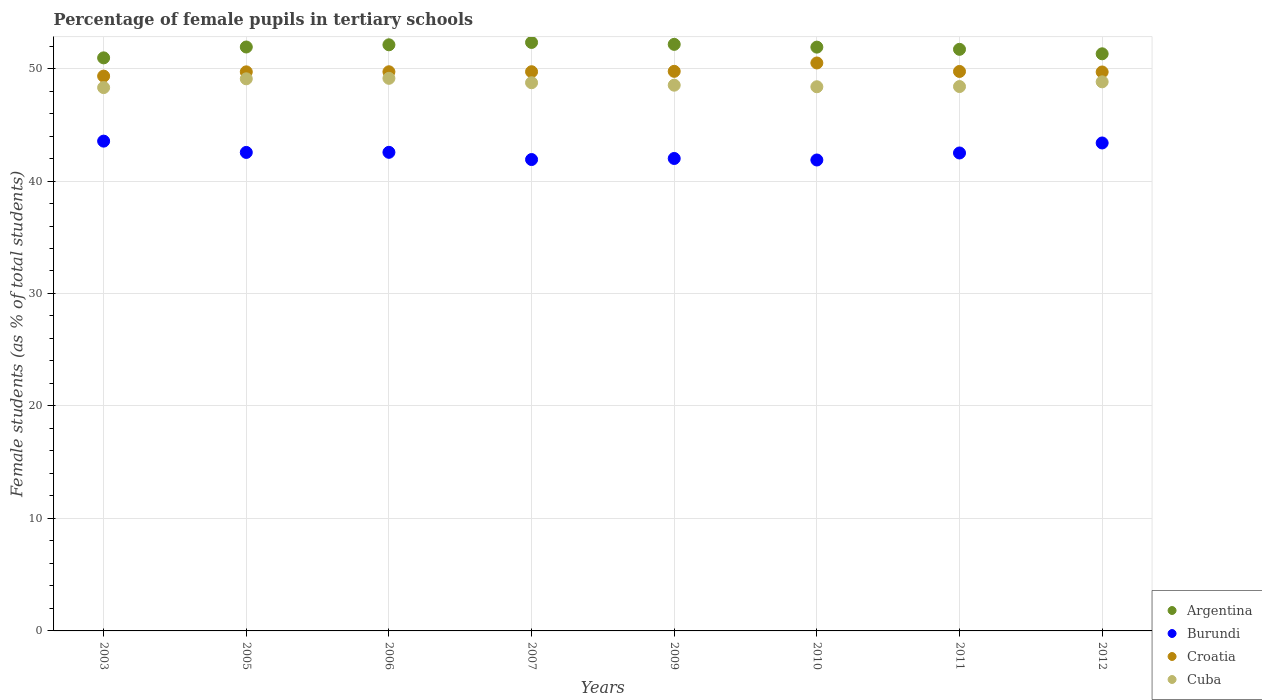How many different coloured dotlines are there?
Ensure brevity in your answer.  4. What is the percentage of female pupils in tertiary schools in Croatia in 2003?
Provide a short and direct response. 49.33. Across all years, what is the maximum percentage of female pupils in tertiary schools in Cuba?
Offer a very short reply. 49.13. Across all years, what is the minimum percentage of female pupils in tertiary schools in Cuba?
Offer a terse response. 48.31. In which year was the percentage of female pupils in tertiary schools in Cuba minimum?
Keep it short and to the point. 2003. What is the total percentage of female pupils in tertiary schools in Burundi in the graph?
Your answer should be very brief. 340.3. What is the difference between the percentage of female pupils in tertiary schools in Burundi in 2005 and that in 2011?
Ensure brevity in your answer.  0.05. What is the difference between the percentage of female pupils in tertiary schools in Croatia in 2003 and the percentage of female pupils in tertiary schools in Burundi in 2012?
Your response must be concise. 5.94. What is the average percentage of female pupils in tertiary schools in Burundi per year?
Your answer should be very brief. 42.54. In the year 2006, what is the difference between the percentage of female pupils in tertiary schools in Cuba and percentage of female pupils in tertiary schools in Burundi?
Your answer should be very brief. 6.58. In how many years, is the percentage of female pupils in tertiary schools in Burundi greater than 44 %?
Give a very brief answer. 0. What is the ratio of the percentage of female pupils in tertiary schools in Argentina in 2007 to that in 2010?
Provide a short and direct response. 1.01. What is the difference between the highest and the second highest percentage of female pupils in tertiary schools in Cuba?
Make the answer very short. 0.04. What is the difference between the highest and the lowest percentage of female pupils in tertiary schools in Cuba?
Keep it short and to the point. 0.82. In how many years, is the percentage of female pupils in tertiary schools in Argentina greater than the average percentage of female pupils in tertiary schools in Argentina taken over all years?
Keep it short and to the point. 5. Is it the case that in every year, the sum of the percentage of female pupils in tertiary schools in Argentina and percentage of female pupils in tertiary schools in Croatia  is greater than the sum of percentage of female pupils in tertiary schools in Cuba and percentage of female pupils in tertiary schools in Burundi?
Your response must be concise. Yes. How many dotlines are there?
Provide a succinct answer. 4. How many years are there in the graph?
Make the answer very short. 8. Are the values on the major ticks of Y-axis written in scientific E-notation?
Offer a very short reply. No. Does the graph contain any zero values?
Ensure brevity in your answer.  No. Does the graph contain grids?
Offer a very short reply. Yes. What is the title of the graph?
Your answer should be very brief. Percentage of female pupils in tertiary schools. What is the label or title of the X-axis?
Make the answer very short. Years. What is the label or title of the Y-axis?
Provide a succinct answer. Female students (as % of total students). What is the Female students (as % of total students) of Argentina in 2003?
Your response must be concise. 50.95. What is the Female students (as % of total students) of Burundi in 2003?
Offer a very short reply. 43.55. What is the Female students (as % of total students) of Croatia in 2003?
Keep it short and to the point. 49.33. What is the Female students (as % of total students) of Cuba in 2003?
Make the answer very short. 48.31. What is the Female students (as % of total students) in Argentina in 2005?
Give a very brief answer. 51.92. What is the Female students (as % of total students) of Burundi in 2005?
Offer a very short reply. 42.54. What is the Female students (as % of total students) in Croatia in 2005?
Give a very brief answer. 49.71. What is the Female students (as % of total students) of Cuba in 2005?
Provide a short and direct response. 49.09. What is the Female students (as % of total students) of Argentina in 2006?
Your answer should be very brief. 52.11. What is the Female students (as % of total students) of Burundi in 2006?
Provide a succinct answer. 42.55. What is the Female students (as % of total students) in Croatia in 2006?
Keep it short and to the point. 49.71. What is the Female students (as % of total students) in Cuba in 2006?
Ensure brevity in your answer.  49.13. What is the Female students (as % of total students) in Argentina in 2007?
Provide a succinct answer. 52.32. What is the Female students (as % of total students) of Burundi in 2007?
Offer a terse response. 41.91. What is the Female students (as % of total students) in Croatia in 2007?
Offer a terse response. 49.72. What is the Female students (as % of total students) in Cuba in 2007?
Provide a succinct answer. 48.74. What is the Female students (as % of total students) of Argentina in 2009?
Ensure brevity in your answer.  52.15. What is the Female students (as % of total students) in Burundi in 2009?
Give a very brief answer. 42. What is the Female students (as % of total students) of Croatia in 2009?
Keep it short and to the point. 49.75. What is the Female students (as % of total students) of Cuba in 2009?
Your response must be concise. 48.52. What is the Female students (as % of total students) in Argentina in 2010?
Your answer should be very brief. 51.9. What is the Female students (as % of total students) of Burundi in 2010?
Your answer should be compact. 41.87. What is the Female students (as % of total students) in Croatia in 2010?
Provide a succinct answer. 50.5. What is the Female students (as % of total students) in Cuba in 2010?
Provide a short and direct response. 48.38. What is the Female students (as % of total students) in Argentina in 2011?
Offer a terse response. 51.71. What is the Female students (as % of total students) of Burundi in 2011?
Provide a short and direct response. 42.49. What is the Female students (as % of total students) of Croatia in 2011?
Provide a short and direct response. 49.74. What is the Female students (as % of total students) in Cuba in 2011?
Keep it short and to the point. 48.4. What is the Female students (as % of total students) of Argentina in 2012?
Your answer should be very brief. 51.31. What is the Female students (as % of total students) in Burundi in 2012?
Provide a short and direct response. 43.38. What is the Female students (as % of total students) in Croatia in 2012?
Provide a short and direct response. 49.69. What is the Female students (as % of total students) in Cuba in 2012?
Your response must be concise. 48.82. Across all years, what is the maximum Female students (as % of total students) in Argentina?
Ensure brevity in your answer.  52.32. Across all years, what is the maximum Female students (as % of total students) in Burundi?
Provide a succinct answer. 43.55. Across all years, what is the maximum Female students (as % of total students) in Croatia?
Provide a succinct answer. 50.5. Across all years, what is the maximum Female students (as % of total students) in Cuba?
Offer a very short reply. 49.13. Across all years, what is the minimum Female students (as % of total students) of Argentina?
Your response must be concise. 50.95. Across all years, what is the minimum Female students (as % of total students) of Burundi?
Your answer should be very brief. 41.87. Across all years, what is the minimum Female students (as % of total students) of Croatia?
Provide a succinct answer. 49.33. Across all years, what is the minimum Female students (as % of total students) in Cuba?
Keep it short and to the point. 48.31. What is the total Female students (as % of total students) in Argentina in the graph?
Your response must be concise. 414.37. What is the total Female students (as % of total students) in Burundi in the graph?
Provide a short and direct response. 340.3. What is the total Female students (as % of total students) of Croatia in the graph?
Make the answer very short. 398.15. What is the total Female students (as % of total students) of Cuba in the graph?
Offer a terse response. 389.38. What is the difference between the Female students (as % of total students) in Argentina in 2003 and that in 2005?
Your response must be concise. -0.97. What is the difference between the Female students (as % of total students) in Croatia in 2003 and that in 2005?
Make the answer very short. -0.38. What is the difference between the Female students (as % of total students) in Cuba in 2003 and that in 2005?
Make the answer very short. -0.78. What is the difference between the Female students (as % of total students) in Argentina in 2003 and that in 2006?
Your answer should be very brief. -1.16. What is the difference between the Female students (as % of total students) of Croatia in 2003 and that in 2006?
Provide a short and direct response. -0.39. What is the difference between the Female students (as % of total students) of Cuba in 2003 and that in 2006?
Your response must be concise. -0.82. What is the difference between the Female students (as % of total students) of Argentina in 2003 and that in 2007?
Your answer should be very brief. -1.37. What is the difference between the Female students (as % of total students) of Burundi in 2003 and that in 2007?
Keep it short and to the point. 1.64. What is the difference between the Female students (as % of total students) of Croatia in 2003 and that in 2007?
Make the answer very short. -0.39. What is the difference between the Female students (as % of total students) of Cuba in 2003 and that in 2007?
Your answer should be very brief. -0.43. What is the difference between the Female students (as % of total students) of Argentina in 2003 and that in 2009?
Your answer should be very brief. -1.2. What is the difference between the Female students (as % of total students) in Burundi in 2003 and that in 2009?
Your response must be concise. 1.54. What is the difference between the Female students (as % of total students) in Croatia in 2003 and that in 2009?
Ensure brevity in your answer.  -0.42. What is the difference between the Female students (as % of total students) in Cuba in 2003 and that in 2009?
Your response must be concise. -0.21. What is the difference between the Female students (as % of total students) of Argentina in 2003 and that in 2010?
Your response must be concise. -0.95. What is the difference between the Female students (as % of total students) in Burundi in 2003 and that in 2010?
Offer a terse response. 1.68. What is the difference between the Female students (as % of total students) in Croatia in 2003 and that in 2010?
Offer a terse response. -1.17. What is the difference between the Female students (as % of total students) in Cuba in 2003 and that in 2010?
Keep it short and to the point. -0.07. What is the difference between the Female students (as % of total students) in Argentina in 2003 and that in 2011?
Offer a terse response. -0.76. What is the difference between the Female students (as % of total students) in Burundi in 2003 and that in 2011?
Your answer should be very brief. 1.05. What is the difference between the Female students (as % of total students) of Croatia in 2003 and that in 2011?
Give a very brief answer. -0.41. What is the difference between the Female students (as % of total students) of Cuba in 2003 and that in 2011?
Give a very brief answer. -0.09. What is the difference between the Female students (as % of total students) in Argentina in 2003 and that in 2012?
Make the answer very short. -0.36. What is the difference between the Female students (as % of total students) in Burundi in 2003 and that in 2012?
Your answer should be compact. 0.16. What is the difference between the Female students (as % of total students) in Croatia in 2003 and that in 2012?
Keep it short and to the point. -0.37. What is the difference between the Female students (as % of total students) in Cuba in 2003 and that in 2012?
Offer a very short reply. -0.51. What is the difference between the Female students (as % of total students) of Argentina in 2005 and that in 2006?
Your answer should be very brief. -0.2. What is the difference between the Female students (as % of total students) in Burundi in 2005 and that in 2006?
Offer a terse response. -0.01. What is the difference between the Female students (as % of total students) of Croatia in 2005 and that in 2006?
Give a very brief answer. -0.01. What is the difference between the Female students (as % of total students) of Cuba in 2005 and that in 2006?
Keep it short and to the point. -0.04. What is the difference between the Female students (as % of total students) in Argentina in 2005 and that in 2007?
Keep it short and to the point. -0.4. What is the difference between the Female students (as % of total students) in Burundi in 2005 and that in 2007?
Make the answer very short. 0.63. What is the difference between the Female students (as % of total students) of Croatia in 2005 and that in 2007?
Offer a terse response. -0.01. What is the difference between the Female students (as % of total students) in Cuba in 2005 and that in 2007?
Your answer should be very brief. 0.35. What is the difference between the Female students (as % of total students) of Argentina in 2005 and that in 2009?
Offer a very short reply. -0.23. What is the difference between the Female students (as % of total students) in Burundi in 2005 and that in 2009?
Give a very brief answer. 0.54. What is the difference between the Female students (as % of total students) in Croatia in 2005 and that in 2009?
Keep it short and to the point. -0.05. What is the difference between the Female students (as % of total students) in Cuba in 2005 and that in 2009?
Your response must be concise. 0.57. What is the difference between the Female students (as % of total students) in Argentina in 2005 and that in 2010?
Ensure brevity in your answer.  0.01. What is the difference between the Female students (as % of total students) of Burundi in 2005 and that in 2010?
Give a very brief answer. 0.67. What is the difference between the Female students (as % of total students) in Croatia in 2005 and that in 2010?
Your response must be concise. -0.79. What is the difference between the Female students (as % of total students) in Cuba in 2005 and that in 2010?
Your answer should be very brief. 0.71. What is the difference between the Female students (as % of total students) in Argentina in 2005 and that in 2011?
Make the answer very short. 0.21. What is the difference between the Female students (as % of total students) of Burundi in 2005 and that in 2011?
Your answer should be very brief. 0.05. What is the difference between the Female students (as % of total students) of Croatia in 2005 and that in 2011?
Make the answer very short. -0.04. What is the difference between the Female students (as % of total students) in Cuba in 2005 and that in 2011?
Your response must be concise. 0.69. What is the difference between the Female students (as % of total students) in Argentina in 2005 and that in 2012?
Make the answer very short. 0.6. What is the difference between the Female students (as % of total students) in Burundi in 2005 and that in 2012?
Your response must be concise. -0.84. What is the difference between the Female students (as % of total students) of Croatia in 2005 and that in 2012?
Offer a terse response. 0.01. What is the difference between the Female students (as % of total students) of Cuba in 2005 and that in 2012?
Provide a short and direct response. 0.27. What is the difference between the Female students (as % of total students) of Argentina in 2006 and that in 2007?
Keep it short and to the point. -0.21. What is the difference between the Female students (as % of total students) in Burundi in 2006 and that in 2007?
Give a very brief answer. 0.64. What is the difference between the Female students (as % of total students) in Croatia in 2006 and that in 2007?
Provide a succinct answer. -0. What is the difference between the Female students (as % of total students) in Cuba in 2006 and that in 2007?
Provide a succinct answer. 0.39. What is the difference between the Female students (as % of total students) of Argentina in 2006 and that in 2009?
Make the answer very short. -0.04. What is the difference between the Female students (as % of total students) of Burundi in 2006 and that in 2009?
Your answer should be very brief. 0.55. What is the difference between the Female students (as % of total students) of Croatia in 2006 and that in 2009?
Offer a very short reply. -0.04. What is the difference between the Female students (as % of total students) of Cuba in 2006 and that in 2009?
Provide a short and direct response. 0.61. What is the difference between the Female students (as % of total students) of Argentina in 2006 and that in 2010?
Your response must be concise. 0.21. What is the difference between the Female students (as % of total students) of Burundi in 2006 and that in 2010?
Your answer should be very brief. 0.68. What is the difference between the Female students (as % of total students) of Croatia in 2006 and that in 2010?
Keep it short and to the point. -0.78. What is the difference between the Female students (as % of total students) of Cuba in 2006 and that in 2010?
Your answer should be compact. 0.75. What is the difference between the Female students (as % of total students) of Argentina in 2006 and that in 2011?
Give a very brief answer. 0.4. What is the difference between the Female students (as % of total students) in Burundi in 2006 and that in 2011?
Your answer should be very brief. 0.06. What is the difference between the Female students (as % of total students) in Croatia in 2006 and that in 2011?
Your answer should be very brief. -0.03. What is the difference between the Female students (as % of total students) of Cuba in 2006 and that in 2011?
Provide a short and direct response. 0.73. What is the difference between the Female students (as % of total students) of Burundi in 2006 and that in 2012?
Provide a short and direct response. -0.83. What is the difference between the Female students (as % of total students) in Croatia in 2006 and that in 2012?
Keep it short and to the point. 0.02. What is the difference between the Female students (as % of total students) of Cuba in 2006 and that in 2012?
Make the answer very short. 0.31. What is the difference between the Female students (as % of total students) in Argentina in 2007 and that in 2009?
Offer a very short reply. 0.17. What is the difference between the Female students (as % of total students) of Burundi in 2007 and that in 2009?
Ensure brevity in your answer.  -0.09. What is the difference between the Female students (as % of total students) of Croatia in 2007 and that in 2009?
Make the answer very short. -0.03. What is the difference between the Female students (as % of total students) of Cuba in 2007 and that in 2009?
Your answer should be very brief. 0.22. What is the difference between the Female students (as % of total students) of Argentina in 2007 and that in 2010?
Provide a succinct answer. 0.42. What is the difference between the Female students (as % of total students) in Burundi in 2007 and that in 2010?
Provide a short and direct response. 0.04. What is the difference between the Female students (as % of total students) in Croatia in 2007 and that in 2010?
Your response must be concise. -0.78. What is the difference between the Female students (as % of total students) of Cuba in 2007 and that in 2010?
Offer a very short reply. 0.36. What is the difference between the Female students (as % of total students) in Argentina in 2007 and that in 2011?
Make the answer very short. 0.61. What is the difference between the Female students (as % of total students) in Burundi in 2007 and that in 2011?
Offer a very short reply. -0.58. What is the difference between the Female students (as % of total students) in Croatia in 2007 and that in 2011?
Your answer should be compact. -0.02. What is the difference between the Female students (as % of total students) in Cuba in 2007 and that in 2011?
Your answer should be compact. 0.34. What is the difference between the Female students (as % of total students) of Argentina in 2007 and that in 2012?
Make the answer very short. 1.01. What is the difference between the Female students (as % of total students) of Burundi in 2007 and that in 2012?
Provide a short and direct response. -1.47. What is the difference between the Female students (as % of total students) of Croatia in 2007 and that in 2012?
Offer a terse response. 0.02. What is the difference between the Female students (as % of total students) of Cuba in 2007 and that in 2012?
Your response must be concise. -0.08. What is the difference between the Female students (as % of total students) in Argentina in 2009 and that in 2010?
Keep it short and to the point. 0.25. What is the difference between the Female students (as % of total students) of Burundi in 2009 and that in 2010?
Your response must be concise. 0.13. What is the difference between the Female students (as % of total students) of Croatia in 2009 and that in 2010?
Ensure brevity in your answer.  -0.74. What is the difference between the Female students (as % of total students) in Cuba in 2009 and that in 2010?
Keep it short and to the point. 0.14. What is the difference between the Female students (as % of total students) in Argentina in 2009 and that in 2011?
Offer a terse response. 0.44. What is the difference between the Female students (as % of total students) of Burundi in 2009 and that in 2011?
Provide a succinct answer. -0.49. What is the difference between the Female students (as % of total students) in Croatia in 2009 and that in 2011?
Offer a very short reply. 0.01. What is the difference between the Female students (as % of total students) in Cuba in 2009 and that in 2011?
Your response must be concise. 0.12. What is the difference between the Female students (as % of total students) of Argentina in 2009 and that in 2012?
Your answer should be compact. 0.84. What is the difference between the Female students (as % of total students) of Burundi in 2009 and that in 2012?
Keep it short and to the point. -1.38. What is the difference between the Female students (as % of total students) of Croatia in 2009 and that in 2012?
Make the answer very short. 0.06. What is the difference between the Female students (as % of total students) of Cuba in 2009 and that in 2012?
Give a very brief answer. -0.3. What is the difference between the Female students (as % of total students) of Argentina in 2010 and that in 2011?
Keep it short and to the point. 0.2. What is the difference between the Female students (as % of total students) in Burundi in 2010 and that in 2011?
Your answer should be very brief. -0.62. What is the difference between the Female students (as % of total students) in Croatia in 2010 and that in 2011?
Provide a succinct answer. 0.75. What is the difference between the Female students (as % of total students) in Cuba in 2010 and that in 2011?
Give a very brief answer. -0.02. What is the difference between the Female students (as % of total students) of Argentina in 2010 and that in 2012?
Your answer should be compact. 0.59. What is the difference between the Female students (as % of total students) of Burundi in 2010 and that in 2012?
Provide a short and direct response. -1.51. What is the difference between the Female students (as % of total students) of Croatia in 2010 and that in 2012?
Ensure brevity in your answer.  0.8. What is the difference between the Female students (as % of total students) in Cuba in 2010 and that in 2012?
Give a very brief answer. -0.44. What is the difference between the Female students (as % of total students) of Argentina in 2011 and that in 2012?
Ensure brevity in your answer.  0.4. What is the difference between the Female students (as % of total students) in Burundi in 2011 and that in 2012?
Ensure brevity in your answer.  -0.89. What is the difference between the Female students (as % of total students) of Croatia in 2011 and that in 2012?
Ensure brevity in your answer.  0.05. What is the difference between the Female students (as % of total students) in Cuba in 2011 and that in 2012?
Your response must be concise. -0.42. What is the difference between the Female students (as % of total students) of Argentina in 2003 and the Female students (as % of total students) of Burundi in 2005?
Your answer should be very brief. 8.41. What is the difference between the Female students (as % of total students) of Argentina in 2003 and the Female students (as % of total students) of Croatia in 2005?
Offer a very short reply. 1.24. What is the difference between the Female students (as % of total students) of Argentina in 2003 and the Female students (as % of total students) of Cuba in 2005?
Give a very brief answer. 1.86. What is the difference between the Female students (as % of total students) of Burundi in 2003 and the Female students (as % of total students) of Croatia in 2005?
Ensure brevity in your answer.  -6.16. What is the difference between the Female students (as % of total students) of Burundi in 2003 and the Female students (as % of total students) of Cuba in 2005?
Your response must be concise. -5.54. What is the difference between the Female students (as % of total students) in Croatia in 2003 and the Female students (as % of total students) in Cuba in 2005?
Provide a succinct answer. 0.24. What is the difference between the Female students (as % of total students) of Argentina in 2003 and the Female students (as % of total students) of Burundi in 2006?
Give a very brief answer. 8.4. What is the difference between the Female students (as % of total students) in Argentina in 2003 and the Female students (as % of total students) in Croatia in 2006?
Make the answer very short. 1.24. What is the difference between the Female students (as % of total students) in Argentina in 2003 and the Female students (as % of total students) in Cuba in 2006?
Make the answer very short. 1.82. What is the difference between the Female students (as % of total students) of Burundi in 2003 and the Female students (as % of total students) of Croatia in 2006?
Ensure brevity in your answer.  -6.17. What is the difference between the Female students (as % of total students) of Burundi in 2003 and the Female students (as % of total students) of Cuba in 2006?
Offer a very short reply. -5.58. What is the difference between the Female students (as % of total students) of Croatia in 2003 and the Female students (as % of total students) of Cuba in 2006?
Your answer should be compact. 0.2. What is the difference between the Female students (as % of total students) in Argentina in 2003 and the Female students (as % of total students) in Burundi in 2007?
Make the answer very short. 9.04. What is the difference between the Female students (as % of total students) of Argentina in 2003 and the Female students (as % of total students) of Croatia in 2007?
Provide a succinct answer. 1.23. What is the difference between the Female students (as % of total students) of Argentina in 2003 and the Female students (as % of total students) of Cuba in 2007?
Provide a succinct answer. 2.21. What is the difference between the Female students (as % of total students) of Burundi in 2003 and the Female students (as % of total students) of Croatia in 2007?
Provide a succinct answer. -6.17. What is the difference between the Female students (as % of total students) of Burundi in 2003 and the Female students (as % of total students) of Cuba in 2007?
Your answer should be compact. -5.19. What is the difference between the Female students (as % of total students) of Croatia in 2003 and the Female students (as % of total students) of Cuba in 2007?
Provide a short and direct response. 0.59. What is the difference between the Female students (as % of total students) in Argentina in 2003 and the Female students (as % of total students) in Burundi in 2009?
Give a very brief answer. 8.95. What is the difference between the Female students (as % of total students) of Argentina in 2003 and the Female students (as % of total students) of Croatia in 2009?
Your answer should be very brief. 1.2. What is the difference between the Female students (as % of total students) in Argentina in 2003 and the Female students (as % of total students) in Cuba in 2009?
Ensure brevity in your answer.  2.43. What is the difference between the Female students (as % of total students) of Burundi in 2003 and the Female students (as % of total students) of Croatia in 2009?
Make the answer very short. -6.21. What is the difference between the Female students (as % of total students) in Burundi in 2003 and the Female students (as % of total students) in Cuba in 2009?
Keep it short and to the point. -4.97. What is the difference between the Female students (as % of total students) of Croatia in 2003 and the Female students (as % of total students) of Cuba in 2009?
Give a very brief answer. 0.81. What is the difference between the Female students (as % of total students) of Argentina in 2003 and the Female students (as % of total students) of Burundi in 2010?
Provide a succinct answer. 9.08. What is the difference between the Female students (as % of total students) in Argentina in 2003 and the Female students (as % of total students) in Croatia in 2010?
Ensure brevity in your answer.  0.45. What is the difference between the Female students (as % of total students) in Argentina in 2003 and the Female students (as % of total students) in Cuba in 2010?
Make the answer very short. 2.57. What is the difference between the Female students (as % of total students) of Burundi in 2003 and the Female students (as % of total students) of Croatia in 2010?
Offer a terse response. -6.95. What is the difference between the Female students (as % of total students) of Burundi in 2003 and the Female students (as % of total students) of Cuba in 2010?
Your answer should be compact. -4.84. What is the difference between the Female students (as % of total students) in Croatia in 2003 and the Female students (as % of total students) in Cuba in 2010?
Provide a short and direct response. 0.95. What is the difference between the Female students (as % of total students) of Argentina in 2003 and the Female students (as % of total students) of Burundi in 2011?
Provide a short and direct response. 8.46. What is the difference between the Female students (as % of total students) in Argentina in 2003 and the Female students (as % of total students) in Croatia in 2011?
Offer a very short reply. 1.21. What is the difference between the Female students (as % of total students) in Argentina in 2003 and the Female students (as % of total students) in Cuba in 2011?
Your response must be concise. 2.55. What is the difference between the Female students (as % of total students) in Burundi in 2003 and the Female students (as % of total students) in Croatia in 2011?
Give a very brief answer. -6.2. What is the difference between the Female students (as % of total students) of Burundi in 2003 and the Female students (as % of total students) of Cuba in 2011?
Ensure brevity in your answer.  -4.85. What is the difference between the Female students (as % of total students) in Croatia in 2003 and the Female students (as % of total students) in Cuba in 2011?
Provide a short and direct response. 0.93. What is the difference between the Female students (as % of total students) in Argentina in 2003 and the Female students (as % of total students) in Burundi in 2012?
Give a very brief answer. 7.57. What is the difference between the Female students (as % of total students) in Argentina in 2003 and the Female students (as % of total students) in Croatia in 2012?
Offer a very short reply. 1.25. What is the difference between the Female students (as % of total students) of Argentina in 2003 and the Female students (as % of total students) of Cuba in 2012?
Offer a terse response. 2.13. What is the difference between the Female students (as % of total students) in Burundi in 2003 and the Female students (as % of total students) in Croatia in 2012?
Your response must be concise. -6.15. What is the difference between the Female students (as % of total students) of Burundi in 2003 and the Female students (as % of total students) of Cuba in 2012?
Your answer should be compact. -5.27. What is the difference between the Female students (as % of total students) of Croatia in 2003 and the Female students (as % of total students) of Cuba in 2012?
Offer a very short reply. 0.51. What is the difference between the Female students (as % of total students) of Argentina in 2005 and the Female students (as % of total students) of Burundi in 2006?
Provide a succinct answer. 9.36. What is the difference between the Female students (as % of total students) in Argentina in 2005 and the Female students (as % of total students) in Croatia in 2006?
Keep it short and to the point. 2.2. What is the difference between the Female students (as % of total students) of Argentina in 2005 and the Female students (as % of total students) of Cuba in 2006?
Provide a short and direct response. 2.79. What is the difference between the Female students (as % of total students) in Burundi in 2005 and the Female students (as % of total students) in Croatia in 2006?
Give a very brief answer. -7.17. What is the difference between the Female students (as % of total students) of Burundi in 2005 and the Female students (as % of total students) of Cuba in 2006?
Offer a terse response. -6.59. What is the difference between the Female students (as % of total students) in Croatia in 2005 and the Female students (as % of total students) in Cuba in 2006?
Give a very brief answer. 0.58. What is the difference between the Female students (as % of total students) of Argentina in 2005 and the Female students (as % of total students) of Burundi in 2007?
Offer a very short reply. 10.01. What is the difference between the Female students (as % of total students) of Argentina in 2005 and the Female students (as % of total students) of Croatia in 2007?
Make the answer very short. 2.2. What is the difference between the Female students (as % of total students) in Argentina in 2005 and the Female students (as % of total students) in Cuba in 2007?
Keep it short and to the point. 3.18. What is the difference between the Female students (as % of total students) of Burundi in 2005 and the Female students (as % of total students) of Croatia in 2007?
Your answer should be very brief. -7.18. What is the difference between the Female students (as % of total students) in Burundi in 2005 and the Female students (as % of total students) in Cuba in 2007?
Give a very brief answer. -6.2. What is the difference between the Female students (as % of total students) in Croatia in 2005 and the Female students (as % of total students) in Cuba in 2007?
Provide a short and direct response. 0.97. What is the difference between the Female students (as % of total students) in Argentina in 2005 and the Female students (as % of total students) in Burundi in 2009?
Offer a terse response. 9.91. What is the difference between the Female students (as % of total students) of Argentina in 2005 and the Female students (as % of total students) of Croatia in 2009?
Offer a very short reply. 2.16. What is the difference between the Female students (as % of total students) of Argentina in 2005 and the Female students (as % of total students) of Cuba in 2009?
Keep it short and to the point. 3.39. What is the difference between the Female students (as % of total students) in Burundi in 2005 and the Female students (as % of total students) in Croatia in 2009?
Your answer should be compact. -7.21. What is the difference between the Female students (as % of total students) of Burundi in 2005 and the Female students (as % of total students) of Cuba in 2009?
Give a very brief answer. -5.98. What is the difference between the Female students (as % of total students) in Croatia in 2005 and the Female students (as % of total students) in Cuba in 2009?
Make the answer very short. 1.19. What is the difference between the Female students (as % of total students) of Argentina in 2005 and the Female students (as % of total students) of Burundi in 2010?
Ensure brevity in your answer.  10.05. What is the difference between the Female students (as % of total students) in Argentina in 2005 and the Female students (as % of total students) in Croatia in 2010?
Give a very brief answer. 1.42. What is the difference between the Female students (as % of total students) of Argentina in 2005 and the Female students (as % of total students) of Cuba in 2010?
Make the answer very short. 3.53. What is the difference between the Female students (as % of total students) of Burundi in 2005 and the Female students (as % of total students) of Croatia in 2010?
Offer a terse response. -7.95. What is the difference between the Female students (as % of total students) of Burundi in 2005 and the Female students (as % of total students) of Cuba in 2010?
Your answer should be compact. -5.84. What is the difference between the Female students (as % of total students) of Croatia in 2005 and the Female students (as % of total students) of Cuba in 2010?
Offer a very short reply. 1.33. What is the difference between the Female students (as % of total students) in Argentina in 2005 and the Female students (as % of total students) in Burundi in 2011?
Give a very brief answer. 9.42. What is the difference between the Female students (as % of total students) of Argentina in 2005 and the Female students (as % of total students) of Croatia in 2011?
Keep it short and to the point. 2.17. What is the difference between the Female students (as % of total students) of Argentina in 2005 and the Female students (as % of total students) of Cuba in 2011?
Your answer should be very brief. 3.52. What is the difference between the Female students (as % of total students) of Burundi in 2005 and the Female students (as % of total students) of Croatia in 2011?
Your answer should be very brief. -7.2. What is the difference between the Female students (as % of total students) of Burundi in 2005 and the Female students (as % of total students) of Cuba in 2011?
Provide a succinct answer. -5.86. What is the difference between the Female students (as % of total students) in Croatia in 2005 and the Female students (as % of total students) in Cuba in 2011?
Provide a short and direct response. 1.31. What is the difference between the Female students (as % of total students) in Argentina in 2005 and the Female students (as % of total students) in Burundi in 2012?
Give a very brief answer. 8.53. What is the difference between the Female students (as % of total students) of Argentina in 2005 and the Female students (as % of total students) of Croatia in 2012?
Your response must be concise. 2.22. What is the difference between the Female students (as % of total students) in Argentina in 2005 and the Female students (as % of total students) in Cuba in 2012?
Your answer should be compact. 3.1. What is the difference between the Female students (as % of total students) in Burundi in 2005 and the Female students (as % of total students) in Croatia in 2012?
Offer a terse response. -7.15. What is the difference between the Female students (as % of total students) in Burundi in 2005 and the Female students (as % of total students) in Cuba in 2012?
Offer a very short reply. -6.28. What is the difference between the Female students (as % of total students) of Croatia in 2005 and the Female students (as % of total students) of Cuba in 2012?
Offer a very short reply. 0.89. What is the difference between the Female students (as % of total students) in Argentina in 2006 and the Female students (as % of total students) in Burundi in 2007?
Provide a short and direct response. 10.2. What is the difference between the Female students (as % of total students) in Argentina in 2006 and the Female students (as % of total students) in Croatia in 2007?
Offer a very short reply. 2.39. What is the difference between the Female students (as % of total students) of Argentina in 2006 and the Female students (as % of total students) of Cuba in 2007?
Your response must be concise. 3.37. What is the difference between the Female students (as % of total students) in Burundi in 2006 and the Female students (as % of total students) in Croatia in 2007?
Make the answer very short. -7.17. What is the difference between the Female students (as % of total students) of Burundi in 2006 and the Female students (as % of total students) of Cuba in 2007?
Offer a terse response. -6.19. What is the difference between the Female students (as % of total students) in Croatia in 2006 and the Female students (as % of total students) in Cuba in 2007?
Offer a terse response. 0.97. What is the difference between the Female students (as % of total students) in Argentina in 2006 and the Female students (as % of total students) in Burundi in 2009?
Your response must be concise. 10.11. What is the difference between the Female students (as % of total students) in Argentina in 2006 and the Female students (as % of total students) in Croatia in 2009?
Your response must be concise. 2.36. What is the difference between the Female students (as % of total students) of Argentina in 2006 and the Female students (as % of total students) of Cuba in 2009?
Your response must be concise. 3.59. What is the difference between the Female students (as % of total students) of Burundi in 2006 and the Female students (as % of total students) of Croatia in 2009?
Ensure brevity in your answer.  -7.2. What is the difference between the Female students (as % of total students) in Burundi in 2006 and the Female students (as % of total students) in Cuba in 2009?
Provide a short and direct response. -5.97. What is the difference between the Female students (as % of total students) of Croatia in 2006 and the Female students (as % of total students) of Cuba in 2009?
Make the answer very short. 1.19. What is the difference between the Female students (as % of total students) of Argentina in 2006 and the Female students (as % of total students) of Burundi in 2010?
Your answer should be very brief. 10.24. What is the difference between the Female students (as % of total students) of Argentina in 2006 and the Female students (as % of total students) of Croatia in 2010?
Provide a short and direct response. 1.62. What is the difference between the Female students (as % of total students) in Argentina in 2006 and the Female students (as % of total students) in Cuba in 2010?
Give a very brief answer. 3.73. What is the difference between the Female students (as % of total students) in Burundi in 2006 and the Female students (as % of total students) in Croatia in 2010?
Provide a succinct answer. -7.94. What is the difference between the Female students (as % of total students) of Burundi in 2006 and the Female students (as % of total students) of Cuba in 2010?
Your answer should be very brief. -5.83. What is the difference between the Female students (as % of total students) of Croatia in 2006 and the Female students (as % of total students) of Cuba in 2010?
Provide a succinct answer. 1.33. What is the difference between the Female students (as % of total students) in Argentina in 2006 and the Female students (as % of total students) in Burundi in 2011?
Offer a very short reply. 9.62. What is the difference between the Female students (as % of total students) in Argentina in 2006 and the Female students (as % of total students) in Croatia in 2011?
Make the answer very short. 2.37. What is the difference between the Female students (as % of total students) of Argentina in 2006 and the Female students (as % of total students) of Cuba in 2011?
Give a very brief answer. 3.71. What is the difference between the Female students (as % of total students) in Burundi in 2006 and the Female students (as % of total students) in Croatia in 2011?
Provide a short and direct response. -7.19. What is the difference between the Female students (as % of total students) in Burundi in 2006 and the Female students (as % of total students) in Cuba in 2011?
Provide a succinct answer. -5.85. What is the difference between the Female students (as % of total students) in Croatia in 2006 and the Female students (as % of total students) in Cuba in 2011?
Provide a succinct answer. 1.31. What is the difference between the Female students (as % of total students) of Argentina in 2006 and the Female students (as % of total students) of Burundi in 2012?
Your answer should be very brief. 8.73. What is the difference between the Female students (as % of total students) of Argentina in 2006 and the Female students (as % of total students) of Croatia in 2012?
Provide a succinct answer. 2.42. What is the difference between the Female students (as % of total students) of Argentina in 2006 and the Female students (as % of total students) of Cuba in 2012?
Ensure brevity in your answer.  3.29. What is the difference between the Female students (as % of total students) in Burundi in 2006 and the Female students (as % of total students) in Croatia in 2012?
Your response must be concise. -7.14. What is the difference between the Female students (as % of total students) of Burundi in 2006 and the Female students (as % of total students) of Cuba in 2012?
Your answer should be very brief. -6.27. What is the difference between the Female students (as % of total students) in Croatia in 2006 and the Female students (as % of total students) in Cuba in 2012?
Ensure brevity in your answer.  0.9. What is the difference between the Female students (as % of total students) in Argentina in 2007 and the Female students (as % of total students) in Burundi in 2009?
Keep it short and to the point. 10.32. What is the difference between the Female students (as % of total students) in Argentina in 2007 and the Female students (as % of total students) in Croatia in 2009?
Your response must be concise. 2.57. What is the difference between the Female students (as % of total students) in Argentina in 2007 and the Female students (as % of total students) in Cuba in 2009?
Your response must be concise. 3.8. What is the difference between the Female students (as % of total students) of Burundi in 2007 and the Female students (as % of total students) of Croatia in 2009?
Offer a terse response. -7.84. What is the difference between the Female students (as % of total students) in Burundi in 2007 and the Female students (as % of total students) in Cuba in 2009?
Your answer should be very brief. -6.61. What is the difference between the Female students (as % of total students) in Croatia in 2007 and the Female students (as % of total students) in Cuba in 2009?
Give a very brief answer. 1.2. What is the difference between the Female students (as % of total students) in Argentina in 2007 and the Female students (as % of total students) in Burundi in 2010?
Your answer should be very brief. 10.45. What is the difference between the Female students (as % of total students) of Argentina in 2007 and the Female students (as % of total students) of Croatia in 2010?
Give a very brief answer. 1.82. What is the difference between the Female students (as % of total students) of Argentina in 2007 and the Female students (as % of total students) of Cuba in 2010?
Give a very brief answer. 3.94. What is the difference between the Female students (as % of total students) of Burundi in 2007 and the Female students (as % of total students) of Croatia in 2010?
Provide a succinct answer. -8.59. What is the difference between the Female students (as % of total students) in Burundi in 2007 and the Female students (as % of total students) in Cuba in 2010?
Your response must be concise. -6.47. What is the difference between the Female students (as % of total students) in Croatia in 2007 and the Female students (as % of total students) in Cuba in 2010?
Keep it short and to the point. 1.34. What is the difference between the Female students (as % of total students) in Argentina in 2007 and the Female students (as % of total students) in Burundi in 2011?
Offer a terse response. 9.83. What is the difference between the Female students (as % of total students) of Argentina in 2007 and the Female students (as % of total students) of Croatia in 2011?
Offer a very short reply. 2.58. What is the difference between the Female students (as % of total students) of Argentina in 2007 and the Female students (as % of total students) of Cuba in 2011?
Make the answer very short. 3.92. What is the difference between the Female students (as % of total students) in Burundi in 2007 and the Female students (as % of total students) in Croatia in 2011?
Make the answer very short. -7.83. What is the difference between the Female students (as % of total students) in Burundi in 2007 and the Female students (as % of total students) in Cuba in 2011?
Your answer should be very brief. -6.49. What is the difference between the Female students (as % of total students) in Croatia in 2007 and the Female students (as % of total students) in Cuba in 2011?
Provide a succinct answer. 1.32. What is the difference between the Female students (as % of total students) of Argentina in 2007 and the Female students (as % of total students) of Burundi in 2012?
Your answer should be compact. 8.94. What is the difference between the Female students (as % of total students) in Argentina in 2007 and the Female students (as % of total students) in Croatia in 2012?
Your answer should be very brief. 2.63. What is the difference between the Female students (as % of total students) of Argentina in 2007 and the Female students (as % of total students) of Cuba in 2012?
Your answer should be very brief. 3.5. What is the difference between the Female students (as % of total students) in Burundi in 2007 and the Female students (as % of total students) in Croatia in 2012?
Provide a succinct answer. -7.78. What is the difference between the Female students (as % of total students) of Burundi in 2007 and the Female students (as % of total students) of Cuba in 2012?
Give a very brief answer. -6.91. What is the difference between the Female students (as % of total students) in Croatia in 2007 and the Female students (as % of total students) in Cuba in 2012?
Give a very brief answer. 0.9. What is the difference between the Female students (as % of total students) in Argentina in 2009 and the Female students (as % of total students) in Burundi in 2010?
Provide a short and direct response. 10.28. What is the difference between the Female students (as % of total students) in Argentina in 2009 and the Female students (as % of total students) in Croatia in 2010?
Give a very brief answer. 1.65. What is the difference between the Female students (as % of total students) of Argentina in 2009 and the Female students (as % of total students) of Cuba in 2010?
Your response must be concise. 3.77. What is the difference between the Female students (as % of total students) in Burundi in 2009 and the Female students (as % of total students) in Croatia in 2010?
Keep it short and to the point. -8.49. What is the difference between the Female students (as % of total students) in Burundi in 2009 and the Female students (as % of total students) in Cuba in 2010?
Offer a terse response. -6.38. What is the difference between the Female students (as % of total students) of Croatia in 2009 and the Female students (as % of total students) of Cuba in 2010?
Give a very brief answer. 1.37. What is the difference between the Female students (as % of total students) of Argentina in 2009 and the Female students (as % of total students) of Burundi in 2011?
Give a very brief answer. 9.66. What is the difference between the Female students (as % of total students) in Argentina in 2009 and the Female students (as % of total students) in Croatia in 2011?
Offer a terse response. 2.41. What is the difference between the Female students (as % of total students) in Argentina in 2009 and the Female students (as % of total students) in Cuba in 2011?
Ensure brevity in your answer.  3.75. What is the difference between the Female students (as % of total students) in Burundi in 2009 and the Female students (as % of total students) in Croatia in 2011?
Keep it short and to the point. -7.74. What is the difference between the Female students (as % of total students) of Burundi in 2009 and the Female students (as % of total students) of Cuba in 2011?
Your response must be concise. -6.4. What is the difference between the Female students (as % of total students) of Croatia in 2009 and the Female students (as % of total students) of Cuba in 2011?
Make the answer very short. 1.35. What is the difference between the Female students (as % of total students) of Argentina in 2009 and the Female students (as % of total students) of Burundi in 2012?
Your answer should be compact. 8.77. What is the difference between the Female students (as % of total students) of Argentina in 2009 and the Female students (as % of total students) of Croatia in 2012?
Your answer should be very brief. 2.45. What is the difference between the Female students (as % of total students) in Argentina in 2009 and the Female students (as % of total students) in Cuba in 2012?
Provide a short and direct response. 3.33. What is the difference between the Female students (as % of total students) in Burundi in 2009 and the Female students (as % of total students) in Croatia in 2012?
Your answer should be very brief. -7.69. What is the difference between the Female students (as % of total students) of Burundi in 2009 and the Female students (as % of total students) of Cuba in 2012?
Offer a very short reply. -6.81. What is the difference between the Female students (as % of total students) in Croatia in 2009 and the Female students (as % of total students) in Cuba in 2012?
Keep it short and to the point. 0.93. What is the difference between the Female students (as % of total students) in Argentina in 2010 and the Female students (as % of total students) in Burundi in 2011?
Make the answer very short. 9.41. What is the difference between the Female students (as % of total students) in Argentina in 2010 and the Female students (as % of total students) in Croatia in 2011?
Give a very brief answer. 2.16. What is the difference between the Female students (as % of total students) of Argentina in 2010 and the Female students (as % of total students) of Cuba in 2011?
Offer a very short reply. 3.5. What is the difference between the Female students (as % of total students) of Burundi in 2010 and the Female students (as % of total students) of Croatia in 2011?
Give a very brief answer. -7.87. What is the difference between the Female students (as % of total students) of Burundi in 2010 and the Female students (as % of total students) of Cuba in 2011?
Provide a short and direct response. -6.53. What is the difference between the Female students (as % of total students) of Croatia in 2010 and the Female students (as % of total students) of Cuba in 2011?
Provide a short and direct response. 2.1. What is the difference between the Female students (as % of total students) in Argentina in 2010 and the Female students (as % of total students) in Burundi in 2012?
Your answer should be very brief. 8.52. What is the difference between the Female students (as % of total students) in Argentina in 2010 and the Female students (as % of total students) in Croatia in 2012?
Offer a very short reply. 2.21. What is the difference between the Female students (as % of total students) in Argentina in 2010 and the Female students (as % of total students) in Cuba in 2012?
Keep it short and to the point. 3.09. What is the difference between the Female students (as % of total students) in Burundi in 2010 and the Female students (as % of total students) in Croatia in 2012?
Offer a very short reply. -7.83. What is the difference between the Female students (as % of total students) of Burundi in 2010 and the Female students (as % of total students) of Cuba in 2012?
Keep it short and to the point. -6.95. What is the difference between the Female students (as % of total students) in Croatia in 2010 and the Female students (as % of total students) in Cuba in 2012?
Your answer should be compact. 1.68. What is the difference between the Female students (as % of total students) in Argentina in 2011 and the Female students (as % of total students) in Burundi in 2012?
Your answer should be compact. 8.33. What is the difference between the Female students (as % of total students) in Argentina in 2011 and the Female students (as % of total students) in Croatia in 2012?
Ensure brevity in your answer.  2.01. What is the difference between the Female students (as % of total students) in Argentina in 2011 and the Female students (as % of total students) in Cuba in 2012?
Make the answer very short. 2.89. What is the difference between the Female students (as % of total students) in Burundi in 2011 and the Female students (as % of total students) in Croatia in 2012?
Provide a short and direct response. -7.2. What is the difference between the Female students (as % of total students) of Burundi in 2011 and the Female students (as % of total students) of Cuba in 2012?
Provide a succinct answer. -6.33. What is the difference between the Female students (as % of total students) of Croatia in 2011 and the Female students (as % of total students) of Cuba in 2012?
Provide a short and direct response. 0.92. What is the average Female students (as % of total students) in Argentina per year?
Your response must be concise. 51.8. What is the average Female students (as % of total students) of Burundi per year?
Give a very brief answer. 42.54. What is the average Female students (as % of total students) in Croatia per year?
Your answer should be very brief. 49.77. What is the average Female students (as % of total students) of Cuba per year?
Offer a terse response. 48.67. In the year 2003, what is the difference between the Female students (as % of total students) of Argentina and Female students (as % of total students) of Burundi?
Ensure brevity in your answer.  7.4. In the year 2003, what is the difference between the Female students (as % of total students) of Argentina and Female students (as % of total students) of Croatia?
Provide a succinct answer. 1.62. In the year 2003, what is the difference between the Female students (as % of total students) of Argentina and Female students (as % of total students) of Cuba?
Give a very brief answer. 2.64. In the year 2003, what is the difference between the Female students (as % of total students) in Burundi and Female students (as % of total students) in Croatia?
Your response must be concise. -5.78. In the year 2003, what is the difference between the Female students (as % of total students) in Burundi and Female students (as % of total students) in Cuba?
Offer a very short reply. -4.76. In the year 2003, what is the difference between the Female students (as % of total students) of Croatia and Female students (as % of total students) of Cuba?
Provide a succinct answer. 1.02. In the year 2005, what is the difference between the Female students (as % of total students) in Argentina and Female students (as % of total students) in Burundi?
Provide a succinct answer. 9.37. In the year 2005, what is the difference between the Female students (as % of total students) of Argentina and Female students (as % of total students) of Croatia?
Ensure brevity in your answer.  2.21. In the year 2005, what is the difference between the Female students (as % of total students) in Argentina and Female students (as % of total students) in Cuba?
Provide a short and direct response. 2.83. In the year 2005, what is the difference between the Female students (as % of total students) of Burundi and Female students (as % of total students) of Croatia?
Make the answer very short. -7.16. In the year 2005, what is the difference between the Female students (as % of total students) of Burundi and Female students (as % of total students) of Cuba?
Keep it short and to the point. -6.55. In the year 2005, what is the difference between the Female students (as % of total students) of Croatia and Female students (as % of total students) of Cuba?
Ensure brevity in your answer.  0.62. In the year 2006, what is the difference between the Female students (as % of total students) in Argentina and Female students (as % of total students) in Burundi?
Give a very brief answer. 9.56. In the year 2006, what is the difference between the Female students (as % of total students) in Argentina and Female students (as % of total students) in Croatia?
Your response must be concise. 2.4. In the year 2006, what is the difference between the Female students (as % of total students) in Argentina and Female students (as % of total students) in Cuba?
Your answer should be compact. 2.98. In the year 2006, what is the difference between the Female students (as % of total students) in Burundi and Female students (as % of total students) in Croatia?
Provide a short and direct response. -7.16. In the year 2006, what is the difference between the Female students (as % of total students) of Burundi and Female students (as % of total students) of Cuba?
Make the answer very short. -6.58. In the year 2006, what is the difference between the Female students (as % of total students) of Croatia and Female students (as % of total students) of Cuba?
Keep it short and to the point. 0.58. In the year 2007, what is the difference between the Female students (as % of total students) in Argentina and Female students (as % of total students) in Burundi?
Your response must be concise. 10.41. In the year 2007, what is the difference between the Female students (as % of total students) of Argentina and Female students (as % of total students) of Croatia?
Ensure brevity in your answer.  2.6. In the year 2007, what is the difference between the Female students (as % of total students) in Argentina and Female students (as % of total students) in Cuba?
Make the answer very short. 3.58. In the year 2007, what is the difference between the Female students (as % of total students) of Burundi and Female students (as % of total students) of Croatia?
Your answer should be compact. -7.81. In the year 2007, what is the difference between the Female students (as % of total students) in Burundi and Female students (as % of total students) in Cuba?
Keep it short and to the point. -6.83. In the year 2007, what is the difference between the Female students (as % of total students) of Croatia and Female students (as % of total students) of Cuba?
Your answer should be very brief. 0.98. In the year 2009, what is the difference between the Female students (as % of total students) in Argentina and Female students (as % of total students) in Burundi?
Your answer should be compact. 10.15. In the year 2009, what is the difference between the Female students (as % of total students) in Argentina and Female students (as % of total students) in Croatia?
Your answer should be very brief. 2.4. In the year 2009, what is the difference between the Female students (as % of total students) of Argentina and Female students (as % of total students) of Cuba?
Offer a terse response. 3.63. In the year 2009, what is the difference between the Female students (as % of total students) in Burundi and Female students (as % of total students) in Croatia?
Offer a very short reply. -7.75. In the year 2009, what is the difference between the Female students (as % of total students) in Burundi and Female students (as % of total students) in Cuba?
Provide a short and direct response. -6.52. In the year 2009, what is the difference between the Female students (as % of total students) in Croatia and Female students (as % of total students) in Cuba?
Ensure brevity in your answer.  1.23. In the year 2010, what is the difference between the Female students (as % of total students) of Argentina and Female students (as % of total students) of Burundi?
Ensure brevity in your answer.  10.03. In the year 2010, what is the difference between the Female students (as % of total students) of Argentina and Female students (as % of total students) of Croatia?
Keep it short and to the point. 1.41. In the year 2010, what is the difference between the Female students (as % of total students) of Argentina and Female students (as % of total students) of Cuba?
Your answer should be very brief. 3.52. In the year 2010, what is the difference between the Female students (as % of total students) in Burundi and Female students (as % of total students) in Croatia?
Keep it short and to the point. -8.63. In the year 2010, what is the difference between the Female students (as % of total students) of Burundi and Female students (as % of total students) of Cuba?
Ensure brevity in your answer.  -6.51. In the year 2010, what is the difference between the Female students (as % of total students) of Croatia and Female students (as % of total students) of Cuba?
Offer a very short reply. 2.11. In the year 2011, what is the difference between the Female students (as % of total students) in Argentina and Female students (as % of total students) in Burundi?
Your answer should be very brief. 9.22. In the year 2011, what is the difference between the Female students (as % of total students) of Argentina and Female students (as % of total students) of Croatia?
Give a very brief answer. 1.97. In the year 2011, what is the difference between the Female students (as % of total students) of Argentina and Female students (as % of total students) of Cuba?
Offer a terse response. 3.31. In the year 2011, what is the difference between the Female students (as % of total students) in Burundi and Female students (as % of total students) in Croatia?
Offer a very short reply. -7.25. In the year 2011, what is the difference between the Female students (as % of total students) in Burundi and Female students (as % of total students) in Cuba?
Your response must be concise. -5.91. In the year 2011, what is the difference between the Female students (as % of total students) of Croatia and Female students (as % of total students) of Cuba?
Offer a very short reply. 1.34. In the year 2012, what is the difference between the Female students (as % of total students) of Argentina and Female students (as % of total students) of Burundi?
Keep it short and to the point. 7.93. In the year 2012, what is the difference between the Female students (as % of total students) in Argentina and Female students (as % of total students) in Croatia?
Offer a very short reply. 1.62. In the year 2012, what is the difference between the Female students (as % of total students) in Argentina and Female students (as % of total students) in Cuba?
Offer a terse response. 2.49. In the year 2012, what is the difference between the Female students (as % of total students) in Burundi and Female students (as % of total students) in Croatia?
Your answer should be very brief. -6.31. In the year 2012, what is the difference between the Female students (as % of total students) in Burundi and Female students (as % of total students) in Cuba?
Provide a succinct answer. -5.44. In the year 2012, what is the difference between the Female students (as % of total students) in Croatia and Female students (as % of total students) in Cuba?
Provide a short and direct response. 0.88. What is the ratio of the Female students (as % of total students) of Argentina in 2003 to that in 2005?
Offer a very short reply. 0.98. What is the ratio of the Female students (as % of total students) of Burundi in 2003 to that in 2005?
Your answer should be compact. 1.02. What is the ratio of the Female students (as % of total students) in Croatia in 2003 to that in 2005?
Offer a very short reply. 0.99. What is the ratio of the Female students (as % of total students) of Cuba in 2003 to that in 2005?
Make the answer very short. 0.98. What is the ratio of the Female students (as % of total students) of Argentina in 2003 to that in 2006?
Ensure brevity in your answer.  0.98. What is the ratio of the Female students (as % of total students) in Burundi in 2003 to that in 2006?
Your answer should be very brief. 1.02. What is the ratio of the Female students (as % of total students) of Cuba in 2003 to that in 2006?
Your response must be concise. 0.98. What is the ratio of the Female students (as % of total students) of Argentina in 2003 to that in 2007?
Your answer should be very brief. 0.97. What is the ratio of the Female students (as % of total students) in Burundi in 2003 to that in 2007?
Offer a terse response. 1.04. What is the ratio of the Female students (as % of total students) in Argentina in 2003 to that in 2009?
Your answer should be compact. 0.98. What is the ratio of the Female students (as % of total students) of Burundi in 2003 to that in 2009?
Your answer should be compact. 1.04. What is the ratio of the Female students (as % of total students) of Argentina in 2003 to that in 2010?
Give a very brief answer. 0.98. What is the ratio of the Female students (as % of total students) of Burundi in 2003 to that in 2010?
Keep it short and to the point. 1.04. What is the ratio of the Female students (as % of total students) in Croatia in 2003 to that in 2010?
Your response must be concise. 0.98. What is the ratio of the Female students (as % of total students) of Burundi in 2003 to that in 2011?
Ensure brevity in your answer.  1.02. What is the ratio of the Female students (as % of total students) of Argentina in 2003 to that in 2012?
Your answer should be compact. 0.99. What is the ratio of the Female students (as % of total students) in Burundi in 2003 to that in 2012?
Keep it short and to the point. 1. What is the ratio of the Female students (as % of total students) of Burundi in 2005 to that in 2007?
Your answer should be compact. 1.02. What is the ratio of the Female students (as % of total students) of Cuba in 2005 to that in 2007?
Make the answer very short. 1.01. What is the ratio of the Female students (as % of total students) in Argentina in 2005 to that in 2009?
Keep it short and to the point. 1. What is the ratio of the Female students (as % of total students) in Burundi in 2005 to that in 2009?
Your answer should be compact. 1.01. What is the ratio of the Female students (as % of total students) of Cuba in 2005 to that in 2009?
Make the answer very short. 1.01. What is the ratio of the Female students (as % of total students) of Argentina in 2005 to that in 2010?
Your answer should be very brief. 1. What is the ratio of the Female students (as % of total students) of Burundi in 2005 to that in 2010?
Give a very brief answer. 1.02. What is the ratio of the Female students (as % of total students) of Croatia in 2005 to that in 2010?
Ensure brevity in your answer.  0.98. What is the ratio of the Female students (as % of total students) of Cuba in 2005 to that in 2010?
Make the answer very short. 1.01. What is the ratio of the Female students (as % of total students) in Burundi in 2005 to that in 2011?
Provide a short and direct response. 1. What is the ratio of the Female students (as % of total students) of Cuba in 2005 to that in 2011?
Ensure brevity in your answer.  1.01. What is the ratio of the Female students (as % of total students) in Argentina in 2005 to that in 2012?
Provide a succinct answer. 1.01. What is the ratio of the Female students (as % of total students) in Burundi in 2005 to that in 2012?
Offer a terse response. 0.98. What is the ratio of the Female students (as % of total students) in Cuba in 2005 to that in 2012?
Your answer should be compact. 1.01. What is the ratio of the Female students (as % of total students) of Burundi in 2006 to that in 2007?
Your answer should be very brief. 1.02. What is the ratio of the Female students (as % of total students) in Croatia in 2006 to that in 2007?
Provide a short and direct response. 1. What is the ratio of the Female students (as % of total students) in Argentina in 2006 to that in 2009?
Provide a short and direct response. 1. What is the ratio of the Female students (as % of total students) in Cuba in 2006 to that in 2009?
Offer a terse response. 1.01. What is the ratio of the Female students (as % of total students) of Burundi in 2006 to that in 2010?
Offer a terse response. 1.02. What is the ratio of the Female students (as % of total students) of Croatia in 2006 to that in 2010?
Give a very brief answer. 0.98. What is the ratio of the Female students (as % of total students) of Cuba in 2006 to that in 2010?
Offer a terse response. 1.02. What is the ratio of the Female students (as % of total students) in Argentina in 2006 to that in 2011?
Ensure brevity in your answer.  1.01. What is the ratio of the Female students (as % of total students) in Burundi in 2006 to that in 2011?
Keep it short and to the point. 1. What is the ratio of the Female students (as % of total students) of Croatia in 2006 to that in 2011?
Give a very brief answer. 1. What is the ratio of the Female students (as % of total students) in Cuba in 2006 to that in 2011?
Make the answer very short. 1.02. What is the ratio of the Female students (as % of total students) of Argentina in 2006 to that in 2012?
Provide a short and direct response. 1.02. What is the ratio of the Female students (as % of total students) in Burundi in 2006 to that in 2012?
Your answer should be very brief. 0.98. What is the ratio of the Female students (as % of total students) in Cuba in 2006 to that in 2012?
Your answer should be compact. 1.01. What is the ratio of the Female students (as % of total students) of Burundi in 2007 to that in 2009?
Your answer should be compact. 1. What is the ratio of the Female students (as % of total students) in Cuba in 2007 to that in 2009?
Ensure brevity in your answer.  1. What is the ratio of the Female students (as % of total students) of Croatia in 2007 to that in 2010?
Offer a terse response. 0.98. What is the ratio of the Female students (as % of total students) of Cuba in 2007 to that in 2010?
Provide a succinct answer. 1.01. What is the ratio of the Female students (as % of total students) of Argentina in 2007 to that in 2011?
Your answer should be very brief. 1.01. What is the ratio of the Female students (as % of total students) of Burundi in 2007 to that in 2011?
Offer a very short reply. 0.99. What is the ratio of the Female students (as % of total students) in Cuba in 2007 to that in 2011?
Provide a succinct answer. 1.01. What is the ratio of the Female students (as % of total students) in Argentina in 2007 to that in 2012?
Offer a very short reply. 1.02. What is the ratio of the Female students (as % of total students) of Croatia in 2007 to that in 2012?
Make the answer very short. 1. What is the ratio of the Female students (as % of total students) in Burundi in 2009 to that in 2010?
Make the answer very short. 1. What is the ratio of the Female students (as % of total students) of Croatia in 2009 to that in 2010?
Provide a short and direct response. 0.99. What is the ratio of the Female students (as % of total students) of Cuba in 2009 to that in 2010?
Your answer should be compact. 1. What is the ratio of the Female students (as % of total students) of Argentina in 2009 to that in 2011?
Provide a short and direct response. 1.01. What is the ratio of the Female students (as % of total students) in Cuba in 2009 to that in 2011?
Make the answer very short. 1. What is the ratio of the Female students (as % of total students) of Argentina in 2009 to that in 2012?
Ensure brevity in your answer.  1.02. What is the ratio of the Female students (as % of total students) of Burundi in 2009 to that in 2012?
Give a very brief answer. 0.97. What is the ratio of the Female students (as % of total students) of Croatia in 2009 to that in 2012?
Provide a succinct answer. 1. What is the ratio of the Female students (as % of total students) of Cuba in 2009 to that in 2012?
Your answer should be very brief. 0.99. What is the ratio of the Female students (as % of total students) in Croatia in 2010 to that in 2011?
Make the answer very short. 1.02. What is the ratio of the Female students (as % of total students) in Argentina in 2010 to that in 2012?
Make the answer very short. 1.01. What is the ratio of the Female students (as % of total students) in Burundi in 2010 to that in 2012?
Keep it short and to the point. 0.97. What is the ratio of the Female students (as % of total students) in Croatia in 2010 to that in 2012?
Your answer should be compact. 1.02. What is the ratio of the Female students (as % of total students) in Argentina in 2011 to that in 2012?
Offer a very short reply. 1.01. What is the ratio of the Female students (as % of total students) in Burundi in 2011 to that in 2012?
Your answer should be very brief. 0.98. What is the difference between the highest and the second highest Female students (as % of total students) in Argentina?
Provide a succinct answer. 0.17. What is the difference between the highest and the second highest Female students (as % of total students) of Burundi?
Offer a terse response. 0.16. What is the difference between the highest and the second highest Female students (as % of total students) of Croatia?
Give a very brief answer. 0.74. What is the difference between the highest and the second highest Female students (as % of total students) in Cuba?
Provide a succinct answer. 0.04. What is the difference between the highest and the lowest Female students (as % of total students) of Argentina?
Provide a short and direct response. 1.37. What is the difference between the highest and the lowest Female students (as % of total students) of Burundi?
Your answer should be compact. 1.68. What is the difference between the highest and the lowest Female students (as % of total students) in Croatia?
Keep it short and to the point. 1.17. What is the difference between the highest and the lowest Female students (as % of total students) in Cuba?
Keep it short and to the point. 0.82. 